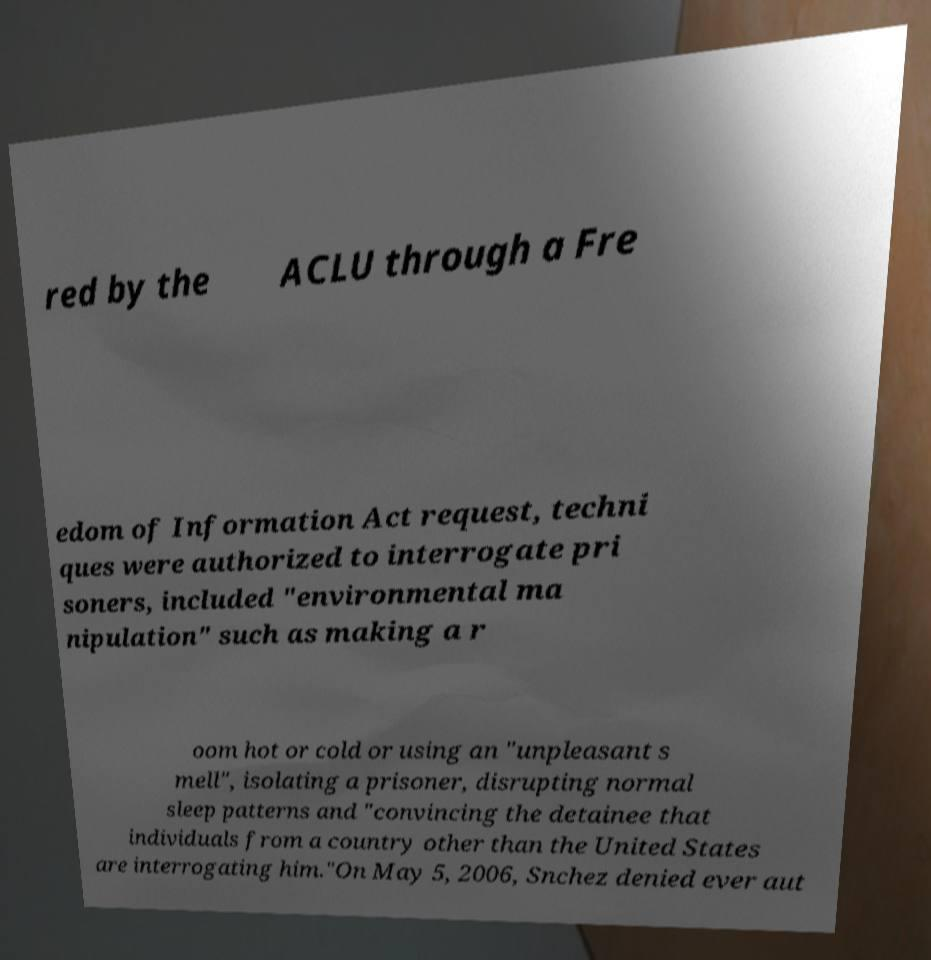What messages or text are displayed in this image? I need them in a readable, typed format. red by the ACLU through a Fre edom of Information Act request, techni ques were authorized to interrogate pri soners, included "environmental ma nipulation" such as making a r oom hot or cold or using an "unpleasant s mell", isolating a prisoner, disrupting normal sleep patterns and "convincing the detainee that individuals from a country other than the United States are interrogating him."On May 5, 2006, Snchez denied ever aut 